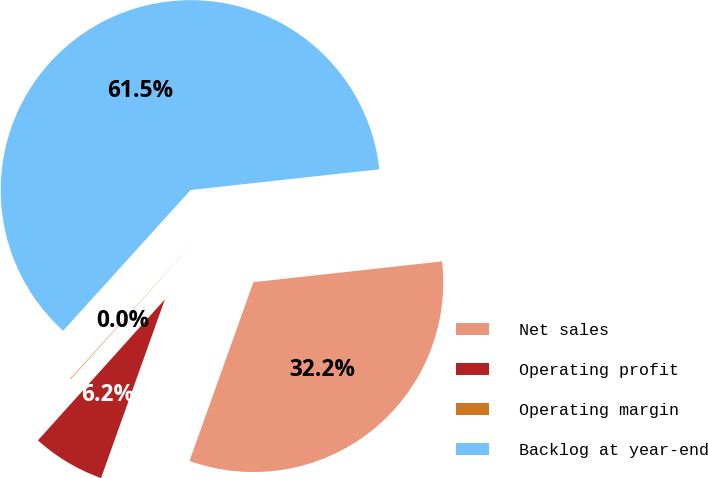Convert chart to OTSL. <chart><loc_0><loc_0><loc_500><loc_500><pie_chart><fcel>Net sales<fcel>Operating profit<fcel>Operating margin<fcel>Backlog at year-end<nl><fcel>32.21%<fcel>6.2%<fcel>0.05%<fcel>61.55%<nl></chart> 